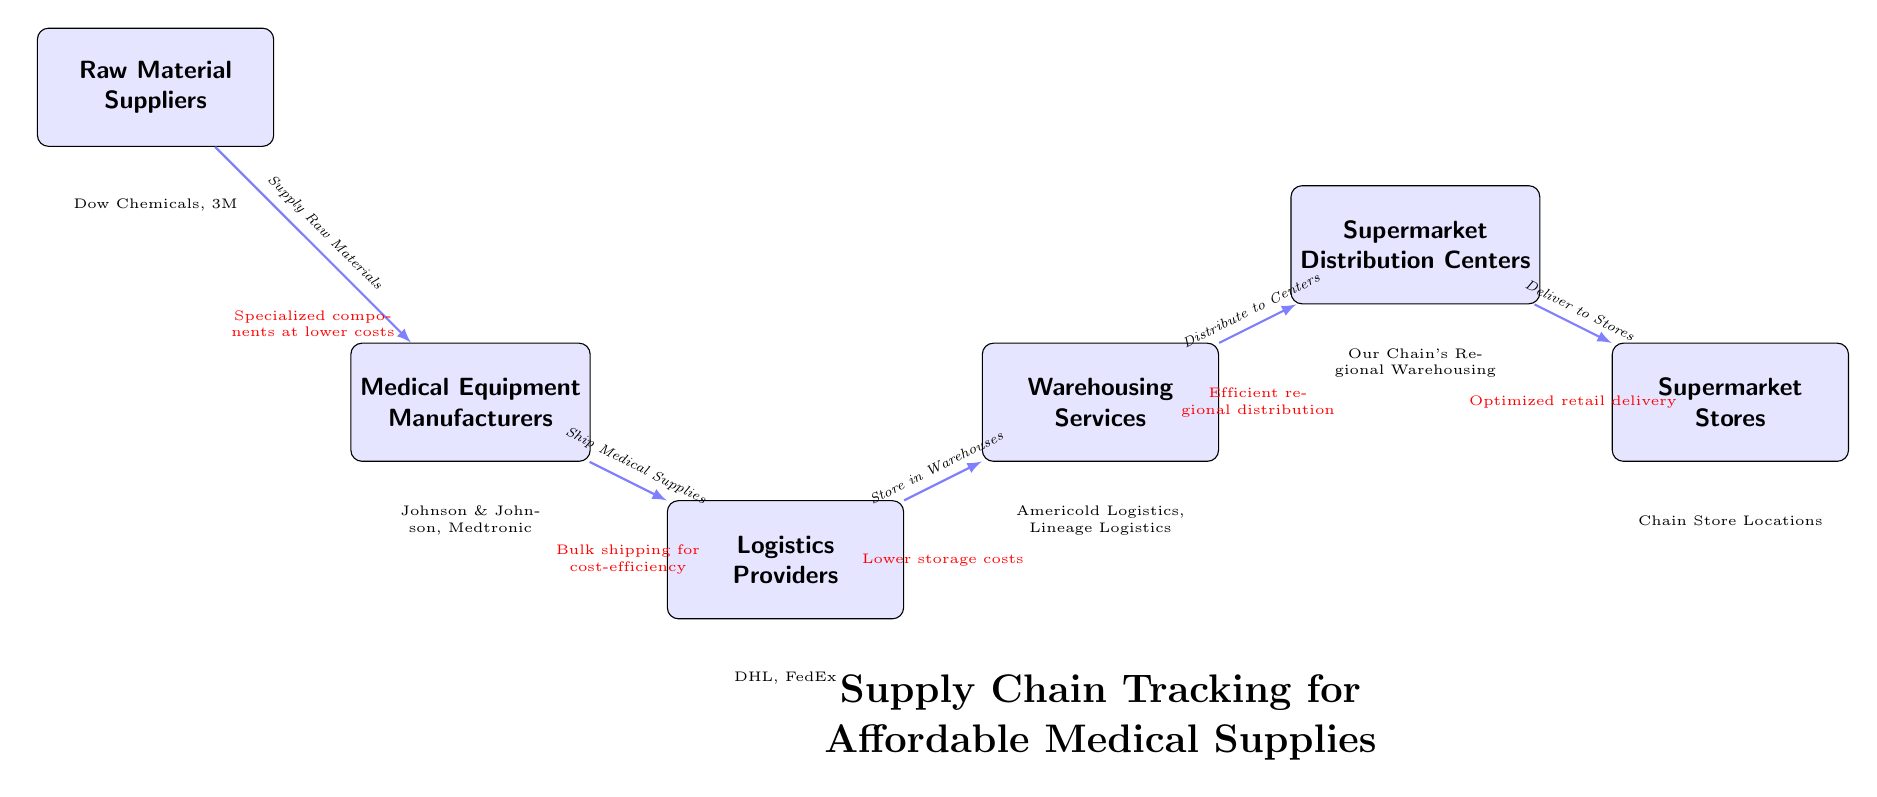What is the first node in the diagram? The diagram starts with the node labeled "Medical Equipment Manufacturers," which is the initial stage in the supply chain.
Answer: Medical Equipment Manufacturers How many main nodes are represented? The diagram displays six main nodes, including the manufacturers, suppliers, logistics, warehousing, distribution centers, and stores.
Answer: 6 Which node represents logistics providers? The node designated for logistics providers is labeled "Logistics Providers," located to the right of the manufacturers in the supply chain flow.
Answer: Logistics Providers What type of advantages are highlighted between the "Warehousing Services" and "Supermarket Distribution Centers" nodes? The advantage illustrated is "Efficient regional distribution," showcasing the cost-saving benefits during this segment of the supply chain process.
Answer: Efficient regional distribution Why is bulk shipping indicated as important in this diagram? Bulk shipping is marked as important as it allows for cost-efficiency, helping to lower expenses while transferring medical supplies from manufacturers to logistics providers.
Answer: Bulk shipping for cost-efficiency What do the colors represent at the advantages directly below the edges? The colors used in the advantages are red, indicating the sources of cost-saving advantages throughout different steps in the supply chain process.
Answer: Red for cost-saving advantages Which companies are listed as raw material suppliers? The raw material suppliers mentioned in the diagram are "Dow Chemicals" and "3M," identifying the sources of raw materials for medical equipment manufacturing.
Answer: Dow Chemicals, 3M What is the final node representing in the supply chain? The final node represents "Supermarket Stores," which is the endpoint of the supply chain where affordable medical supplies are ultimately available to consumers.
Answer: Supermarket Stores Which node benefits from lower storage costs? The node that benefits from lower storage costs is "Warehousing Services," as indicated by the corresponding advantage beneath it in the supply chain representation.
Answer: Warehousing Services 